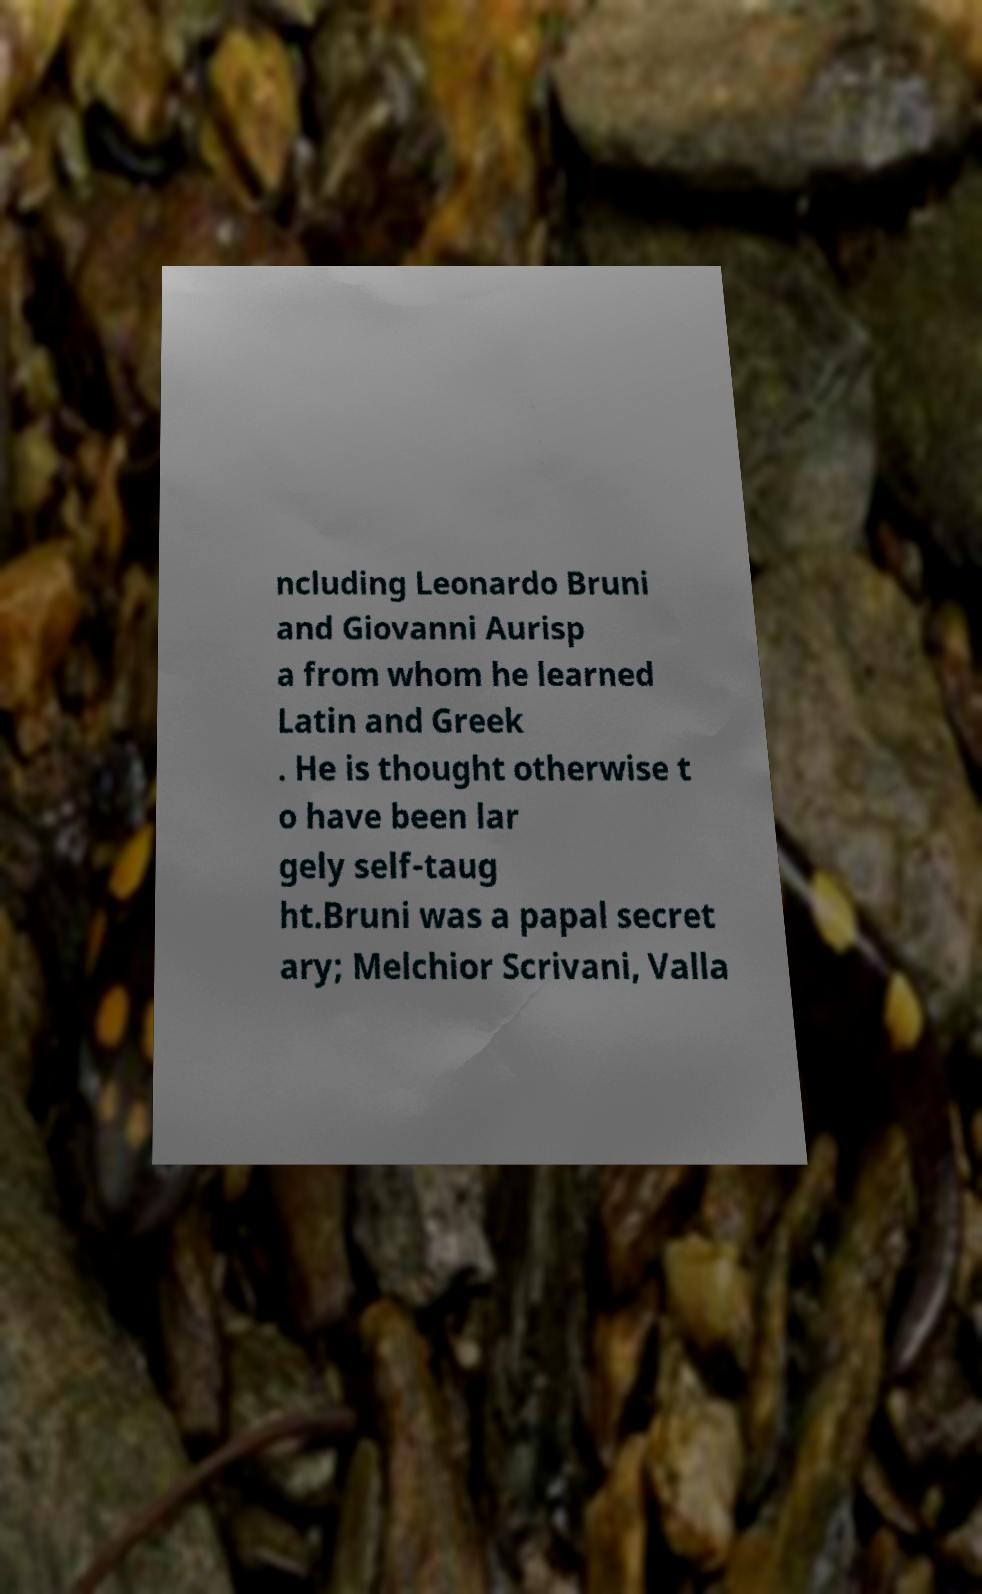Can you accurately transcribe the text from the provided image for me? ncluding Leonardo Bruni and Giovanni Aurisp a from whom he learned Latin and Greek . He is thought otherwise t o have been lar gely self-taug ht.Bruni was a papal secret ary; Melchior Scrivani, Valla 